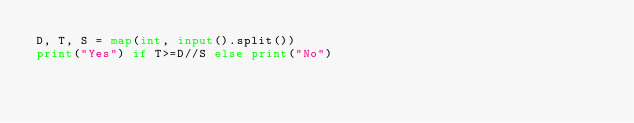<code> <loc_0><loc_0><loc_500><loc_500><_Python_>D, T, S = map(int, input().split())
print("Yes") if T>=D//S else print("No")</code> 